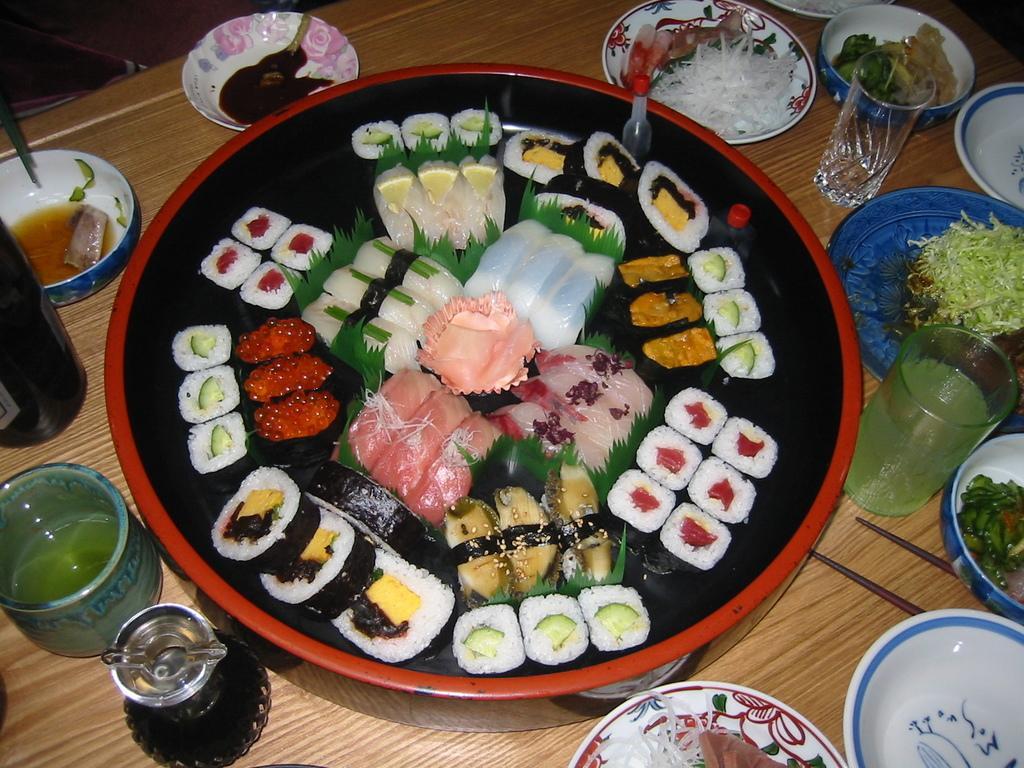Describe this image in one or two sentences. In this image, we can see some food items, eatable things in the bowls and plates are placed on the wooden table. Here we can see chopsticks, glasses, containers and bottle. 